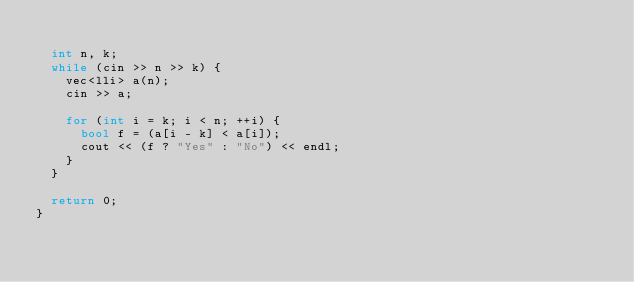Convert code to text. <code><loc_0><loc_0><loc_500><loc_500><_C++_>
  int n, k;
  while (cin >> n >> k) {
    vec<lli> a(n);
    cin >> a;

    for (int i = k; i < n; ++i) {
      bool f = (a[i - k] < a[i]);
      cout << (f ? "Yes" : "No") << endl;
    }
  }

  return 0;
}
</code> 